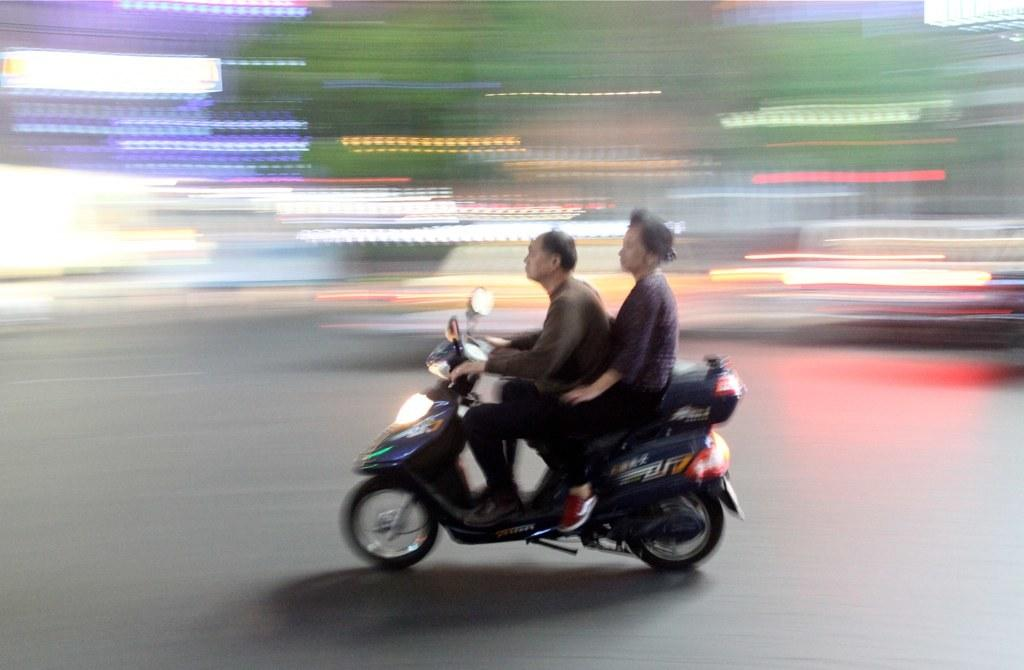What is the main subject of the image? The main subject of the image is a person riding a bike. Where is the person riding the bike? The person is on the road. Is there anyone else with the person riding the bike? Yes, there is another person sitting at the back of the bike. What type of camp can be seen in the background of the image? There is no camp visible in the image; it only shows a person riding a bike with another person at the back. 